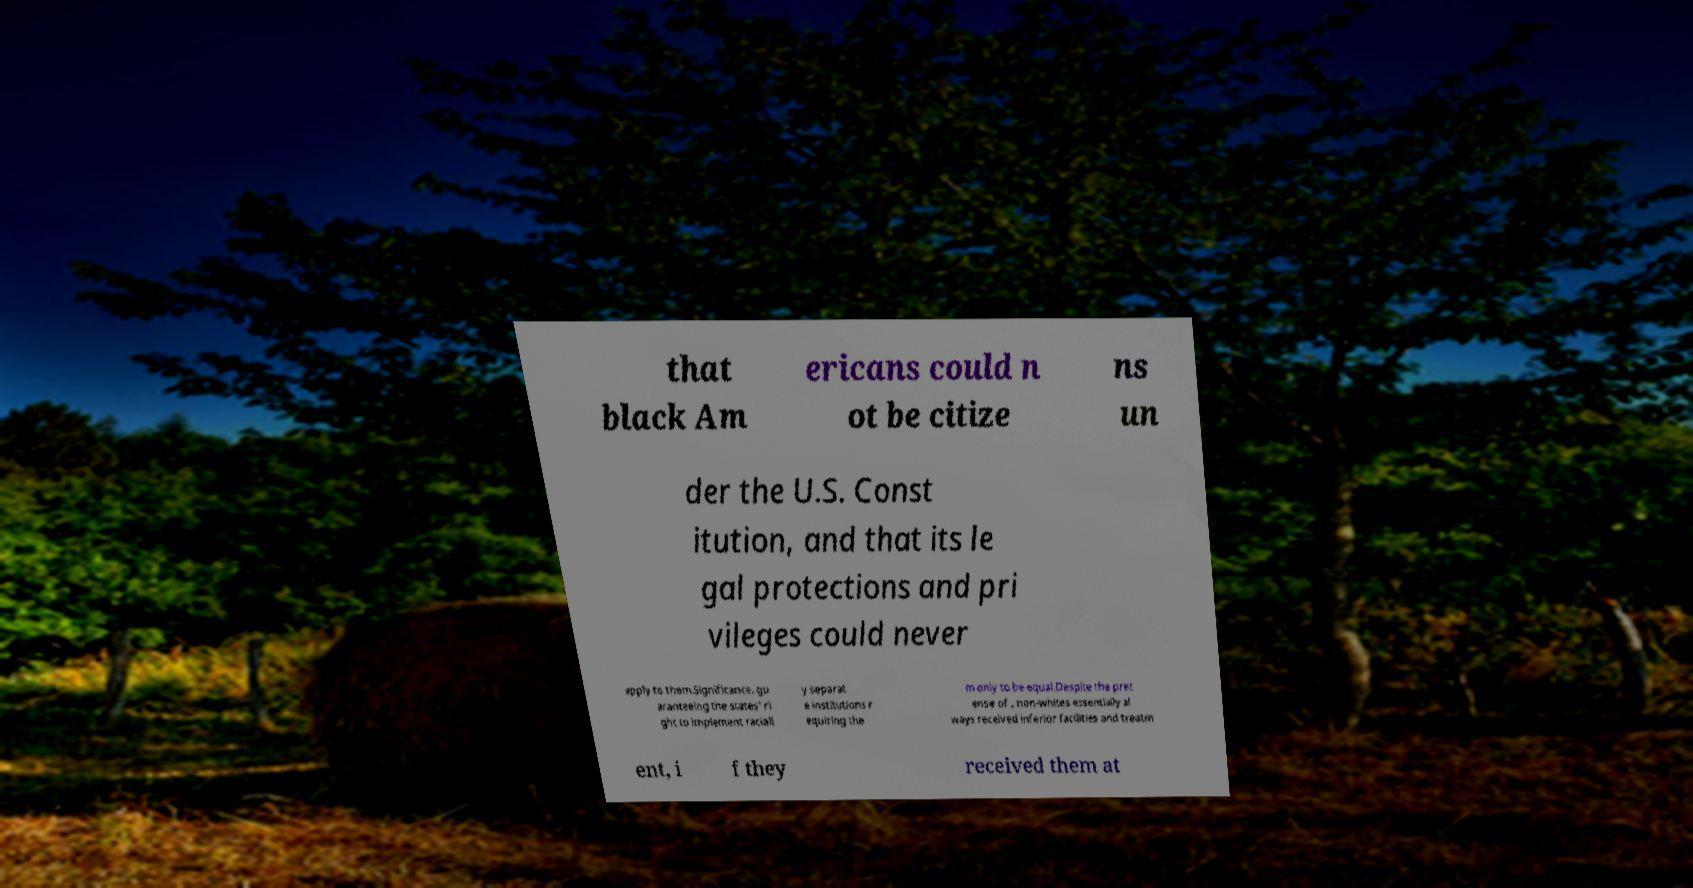What messages or text are displayed in this image? I need them in a readable, typed format. that black Am ericans could n ot be citize ns un der the U.S. Const itution, and that its le gal protections and pri vileges could never apply to them.Significance. gu aranteeing the states' ri ght to implement raciall y separat e institutions r equiring the m only to be equal.Despite the pret ense of , non-whites essentially al ways received inferior facilities and treatm ent, i f they received them at 